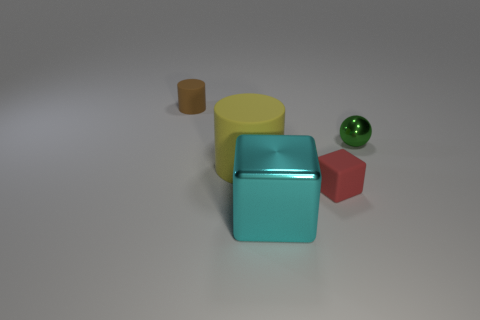What is the material of the object that is on the right side of the big rubber object and on the left side of the red matte block? metal 